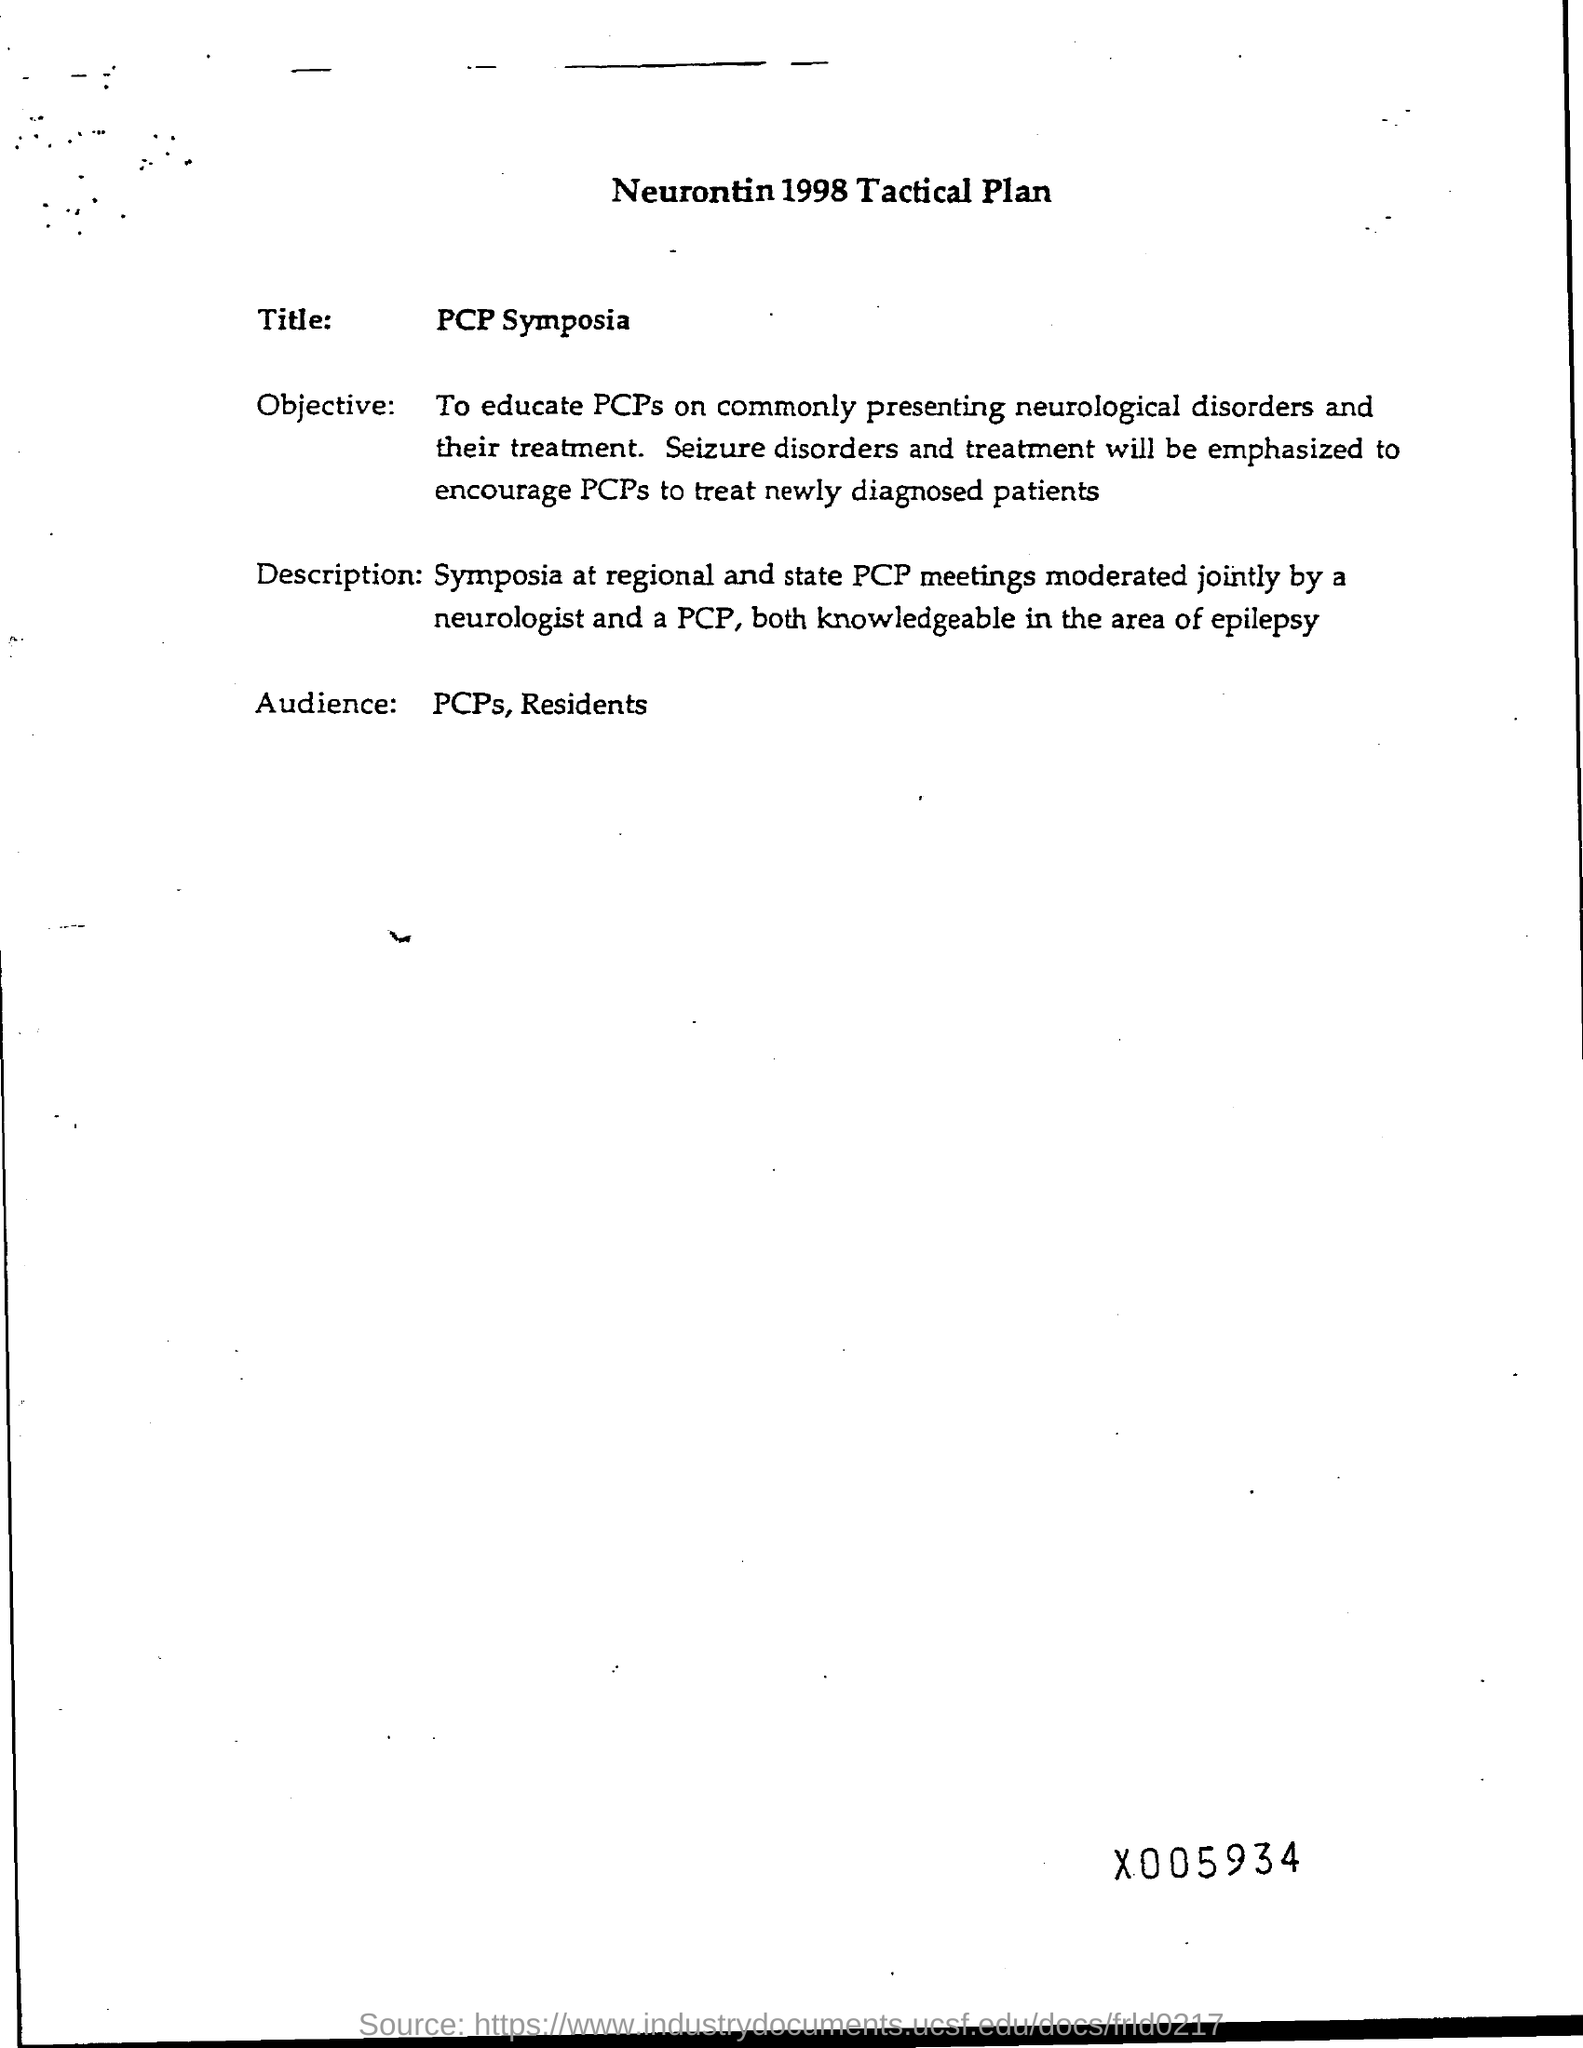Mention a couple of crucial points in this snapshot. The title of the conference is "PCB Symposium. The audience for this presentation will consist of PCPs and residents. The title of the page is 'Neurontin 1998 Tactical Plan.' 